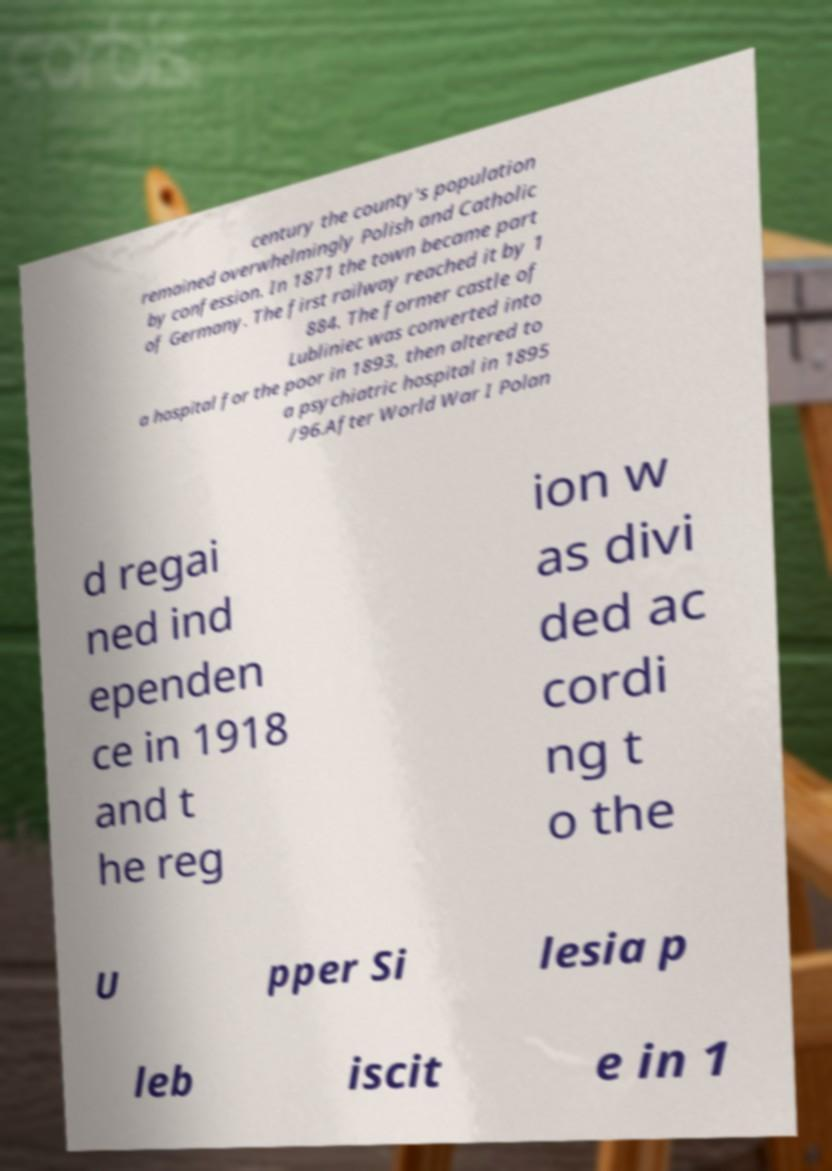I need the written content from this picture converted into text. Can you do that? century the county's population remained overwhelmingly Polish and Catholic by confession. In 1871 the town became part of Germany. The first railway reached it by 1 884. The former castle of Lubliniec was converted into a hospital for the poor in 1893, then altered to a psychiatric hospital in 1895 /96.After World War I Polan d regai ned ind ependen ce in 1918 and t he reg ion w as divi ded ac cordi ng t o the U pper Si lesia p leb iscit e in 1 